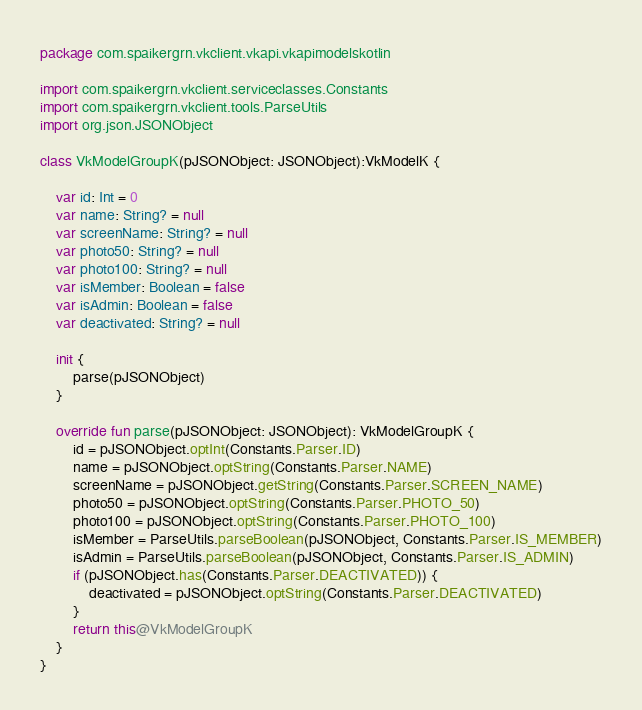<code> <loc_0><loc_0><loc_500><loc_500><_Kotlin_>package com.spaikergrn.vkclient.vkapi.vkapimodelskotlin

import com.spaikergrn.vkclient.serviceclasses.Constants
import com.spaikergrn.vkclient.tools.ParseUtils
import org.json.JSONObject

class VkModelGroupK(pJSONObject: JSONObject):VkModelK {

    var id: Int = 0
    var name: String? = null
    var screenName: String? = null
    var photo50: String? = null
    var photo100: String? = null
    var isMember: Boolean = false
    var isAdmin: Boolean = false
    var deactivated: String? = null

    init {
        parse(pJSONObject)
    }

    override fun parse(pJSONObject: JSONObject): VkModelGroupK {
        id = pJSONObject.optInt(Constants.Parser.ID)
        name = pJSONObject.optString(Constants.Parser.NAME)
        screenName = pJSONObject.getString(Constants.Parser.SCREEN_NAME)
        photo50 = pJSONObject.optString(Constants.Parser.PHOTO_50)
        photo100 = pJSONObject.optString(Constants.Parser.PHOTO_100)
        isMember = ParseUtils.parseBoolean(pJSONObject, Constants.Parser.IS_MEMBER)
        isAdmin = ParseUtils.parseBoolean(pJSONObject, Constants.Parser.IS_ADMIN)
        if (pJSONObject.has(Constants.Parser.DEACTIVATED)) {
            deactivated = pJSONObject.optString(Constants.Parser.DEACTIVATED)
        }
        return this@VkModelGroupK
    }
}</code> 